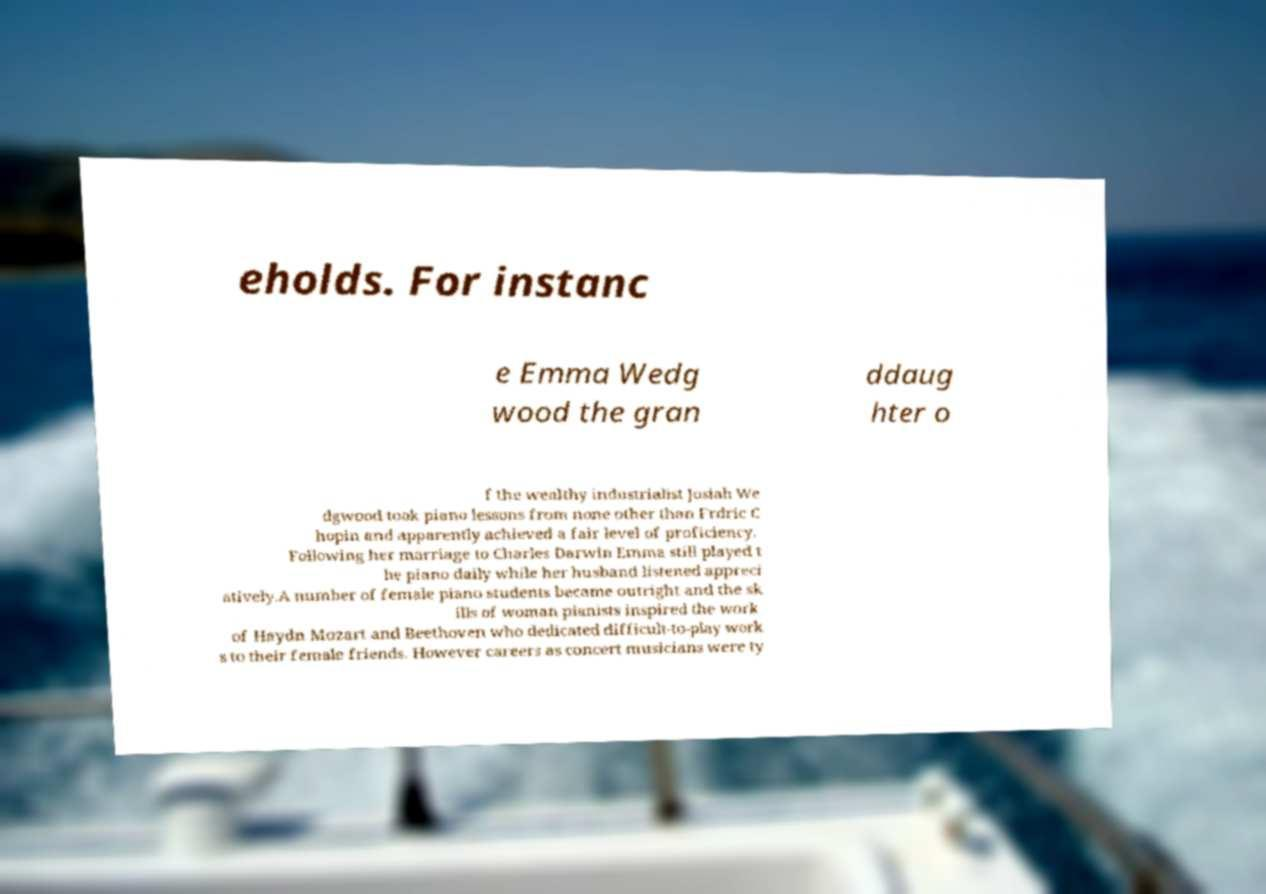What messages or text are displayed in this image? I need them in a readable, typed format. eholds. For instanc e Emma Wedg wood the gran ddaug hter o f the wealthy industrialist Josiah We dgwood took piano lessons from none other than Frdric C hopin and apparently achieved a fair level of proficiency. Following her marriage to Charles Darwin Emma still played t he piano daily while her husband listened appreci atively.A number of female piano students became outright and the sk ills of woman pianists inspired the work of Haydn Mozart and Beethoven who dedicated difficult-to-play work s to their female friends. However careers as concert musicians were ty 